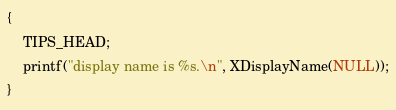Convert code to text. <code><loc_0><loc_0><loc_500><loc_500><_C_>{
    TIPS_HEAD;
    printf("display name is %s.\n", XDisplayName(NULL));
}
</code> 